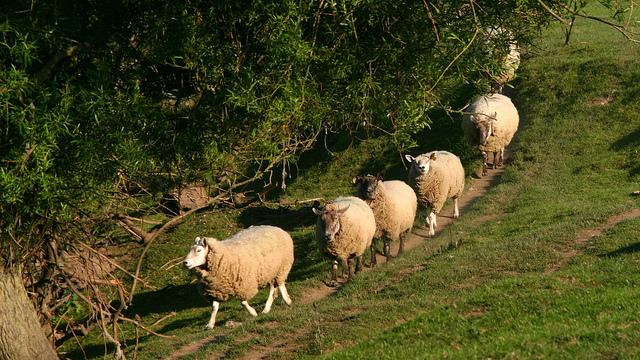Are these sheep recently sheared?
Write a very short answer. No. What are these sheep doing?
Quick response, please. Walking. How many sheep are walking through the grass?
Quick response, please. 6. How many animals are there?
Concise answer only. 6. Are all the sheep standing?
Answer briefly. Yes. How many different species of animals can be seen in this picture?
Concise answer only. 1. How many animals are in the field?
Quick response, please. 6. How many dogs are there?
Answer briefly. 0. What are they doing?
Answer briefly. Walking. Are the animals in the picture identical?
Keep it brief. Yes. 